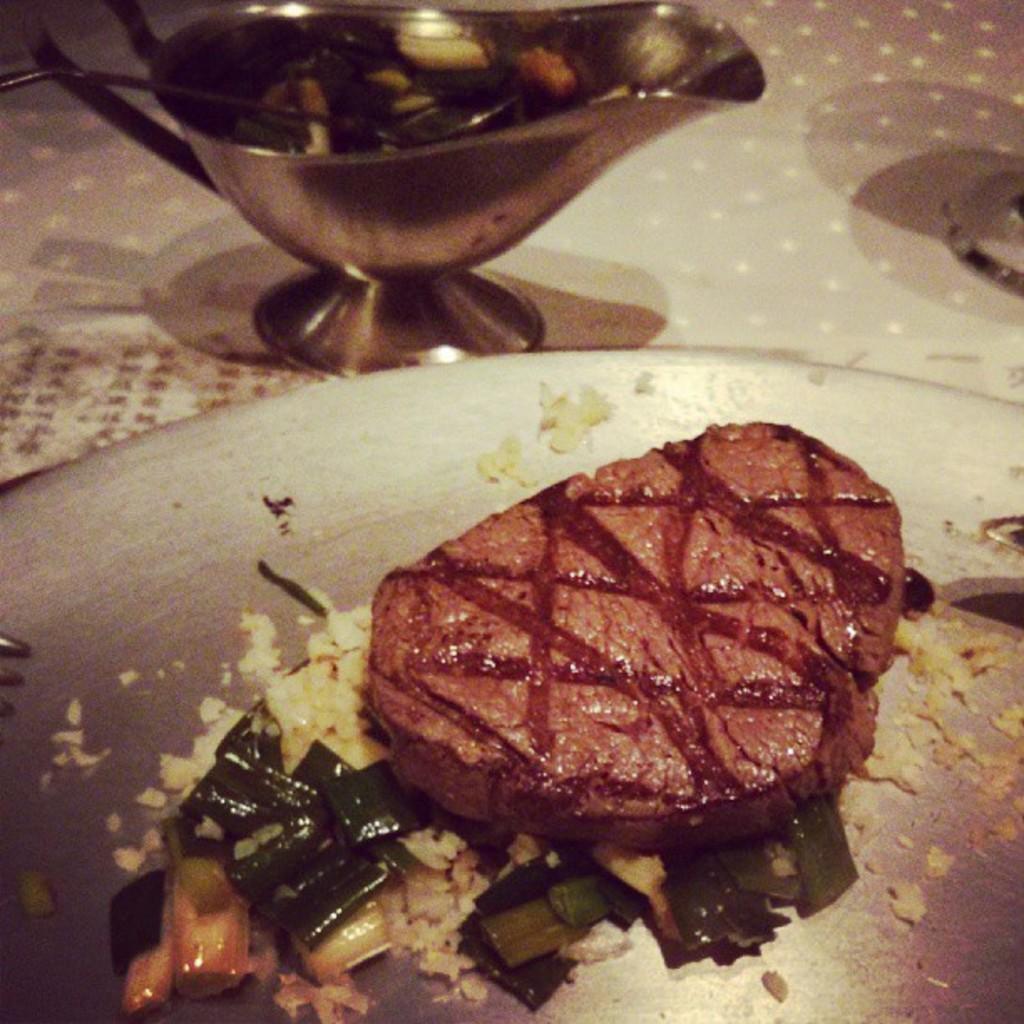How would you summarize this image in a sentence or two? In this image at the bottom there is one plate, in that plate there are some food items and beside the plate there is one bowl. In the bowl there is one spoon, and at the bottom there is a table. 